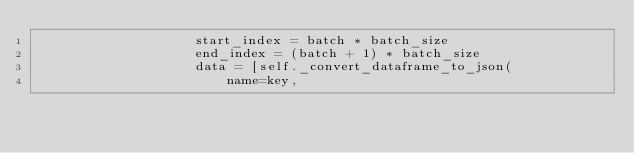Convert code to text. <code><loc_0><loc_0><loc_500><loc_500><_Python_>                    start_index = batch * batch_size
                    end_index = (batch + 1) * batch_size
                    data = [self._convert_dataframe_to_json(
                        name=key,</code> 